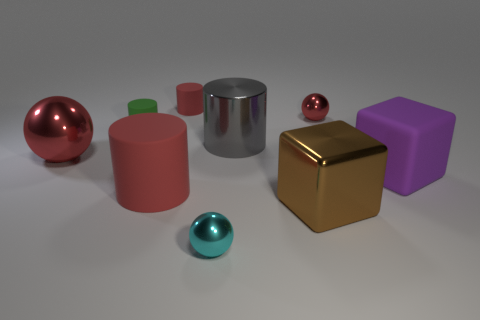Subtract 1 cylinders. How many cylinders are left? 3 Subtract all gray cylinders. How many cylinders are left? 3 Add 1 blue metallic things. How many objects exist? 10 Subtract all big gray cylinders. How many cylinders are left? 3 Subtract all purple cylinders. Subtract all blue blocks. How many cylinders are left? 4 Add 8 large green shiny cylinders. How many large green shiny cylinders exist? 8 Subtract 0 yellow cylinders. How many objects are left? 9 Subtract all cubes. How many objects are left? 7 Subtract all purple rubber balls. Subtract all small red matte objects. How many objects are left? 8 Add 8 large shiny cylinders. How many large shiny cylinders are left? 9 